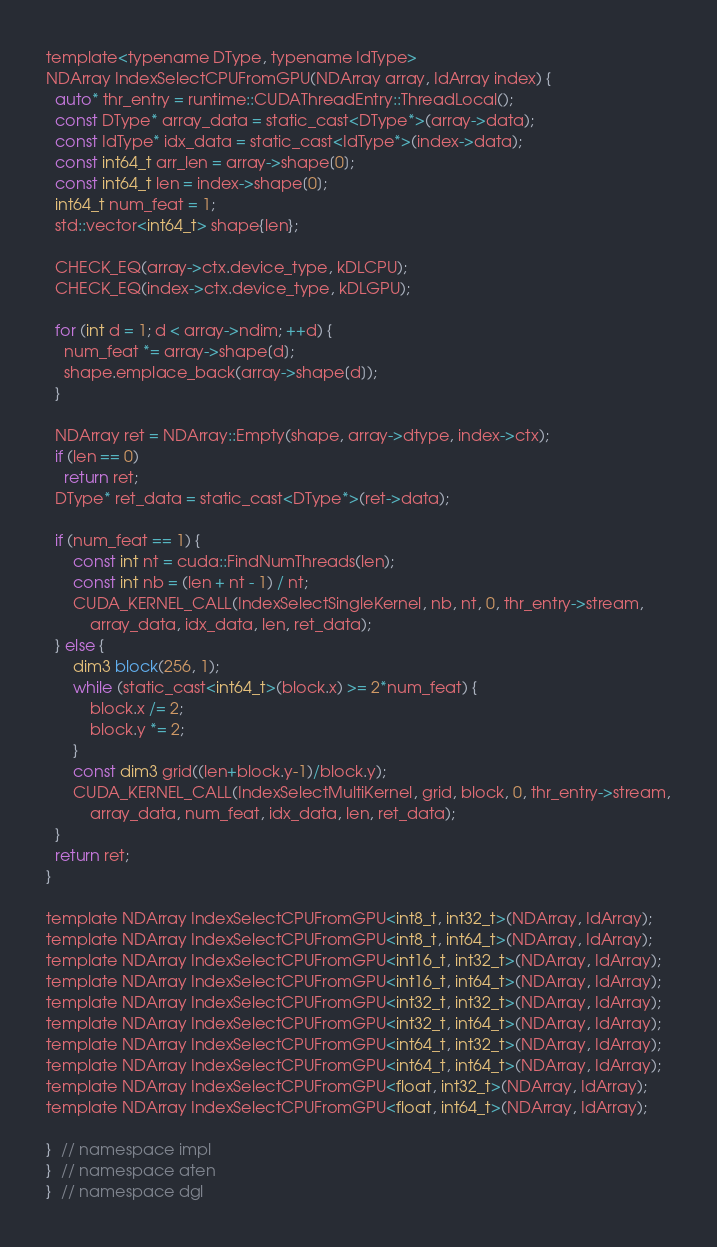<code> <loc_0><loc_0><loc_500><loc_500><_Cuda_>template<typename DType, typename IdType>
NDArray IndexSelectCPUFromGPU(NDArray array, IdArray index) {
  auto* thr_entry = runtime::CUDAThreadEntry::ThreadLocal();
  const DType* array_data = static_cast<DType*>(array->data);
  const IdType* idx_data = static_cast<IdType*>(index->data);
  const int64_t arr_len = array->shape[0];
  const int64_t len = index->shape[0];
  int64_t num_feat = 1;
  std::vector<int64_t> shape{len};

  CHECK_EQ(array->ctx.device_type, kDLCPU);
  CHECK_EQ(index->ctx.device_type, kDLGPU);

  for (int d = 1; d < array->ndim; ++d) {
    num_feat *= array->shape[d];
    shape.emplace_back(array->shape[d]);
  }

  NDArray ret = NDArray::Empty(shape, array->dtype, index->ctx);
  if (len == 0)
    return ret;
  DType* ret_data = static_cast<DType*>(ret->data);

  if (num_feat == 1) {
      const int nt = cuda::FindNumThreads(len);
      const int nb = (len + nt - 1) / nt;
      CUDA_KERNEL_CALL(IndexSelectSingleKernel, nb, nt, 0, thr_entry->stream,
          array_data, idx_data, len, ret_data);
  } else {
      dim3 block(256, 1);
      while (static_cast<int64_t>(block.x) >= 2*num_feat) {
          block.x /= 2;
          block.y *= 2;
      }
      const dim3 grid((len+block.y-1)/block.y);
      CUDA_KERNEL_CALL(IndexSelectMultiKernel, grid, block, 0, thr_entry->stream,
          array_data, num_feat, idx_data, len, ret_data);
  }
  return ret;
}

template NDArray IndexSelectCPUFromGPU<int8_t, int32_t>(NDArray, IdArray);
template NDArray IndexSelectCPUFromGPU<int8_t, int64_t>(NDArray, IdArray);
template NDArray IndexSelectCPUFromGPU<int16_t, int32_t>(NDArray, IdArray);
template NDArray IndexSelectCPUFromGPU<int16_t, int64_t>(NDArray, IdArray);
template NDArray IndexSelectCPUFromGPU<int32_t, int32_t>(NDArray, IdArray);
template NDArray IndexSelectCPUFromGPU<int32_t, int64_t>(NDArray, IdArray);
template NDArray IndexSelectCPUFromGPU<int64_t, int32_t>(NDArray, IdArray);
template NDArray IndexSelectCPUFromGPU<int64_t, int64_t>(NDArray, IdArray);
template NDArray IndexSelectCPUFromGPU<float, int32_t>(NDArray, IdArray);
template NDArray IndexSelectCPUFromGPU<float, int64_t>(NDArray, IdArray);

}  // namespace impl
}  // namespace aten
}  // namespace dgl
</code> 